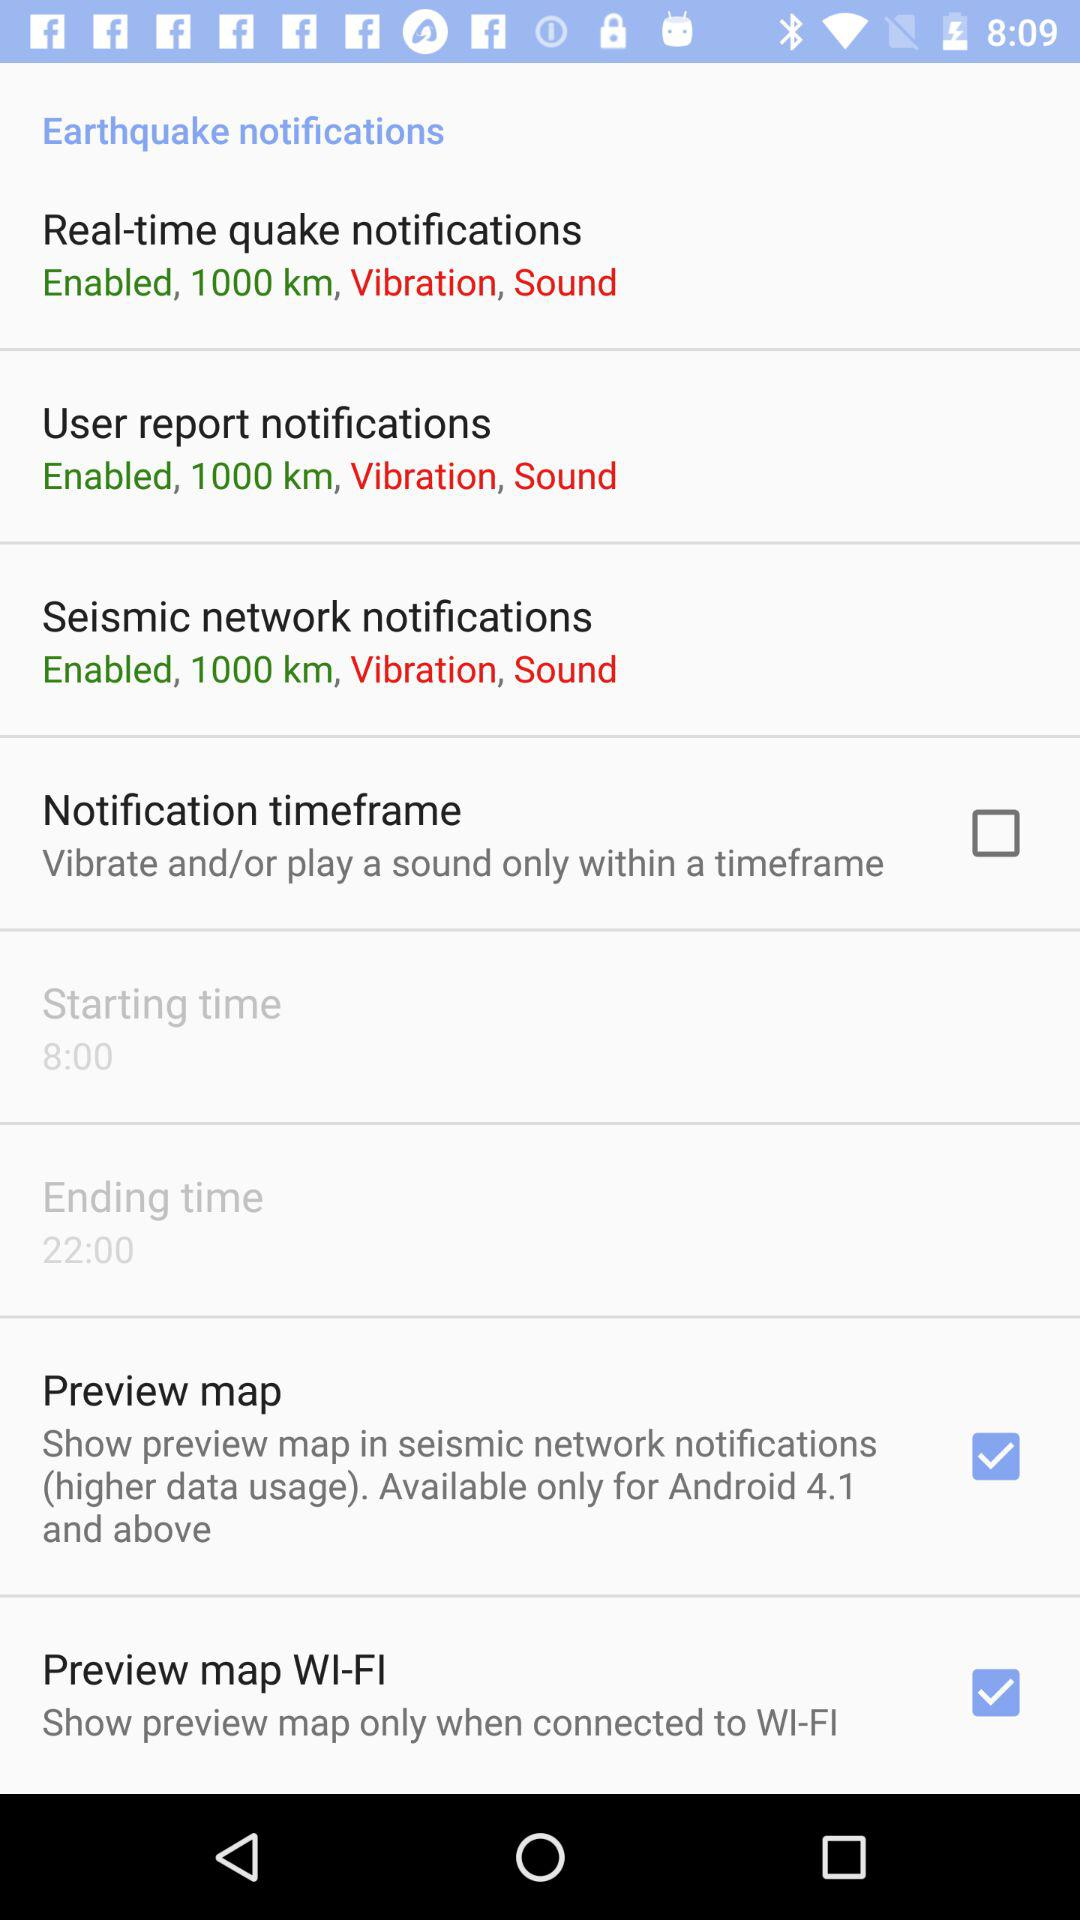What is the status of "Notification timeframe"? The status is "off". 